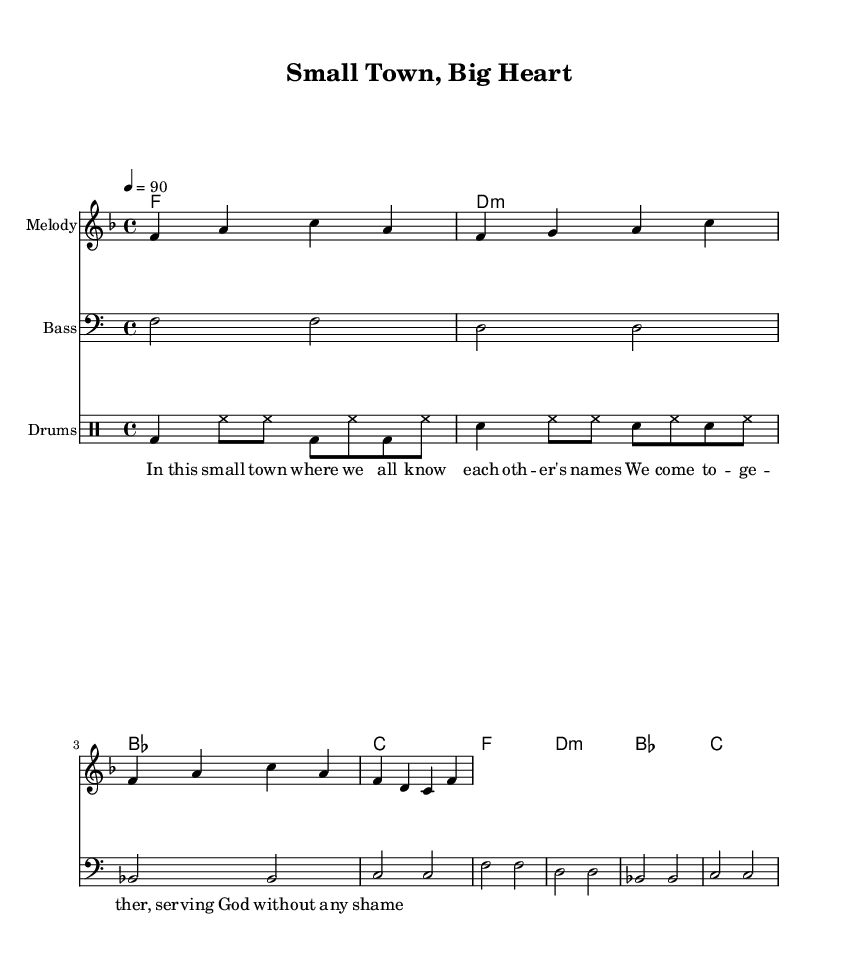What is the title of the piece? The title of the piece is located in the header section of the sheet music. It states "Small Town, Big Heart".
Answer: Small Town, Big Heart What is the time signature of this music? The time signature is indicated near the beginning of the score. It shows a "4/4" which means there are four beats in each measure.
Answer: 4/4 What is the key signature of this music? The key signature is indicated at the beginning of the piece. It shows one flat, which signifies that the piece is in F major.
Answer: F major What is the tempo marking for this piece? The tempo marking is found within the global settings of the score. It indicates "4 = 90", meaning there are 90 beats per minute.
Answer: 90 How many measures are in the melody? The melody section consists of two repeated phrases, each containing four measures. Therefore, there are a total of 8 measures in the melody.
Answer: 8 Which instrument has a bass line in the score? The score includes a specific staff labeled "Bass," indicating that this part is intended for a bass instrument.
Answer: Bass What are the main themes explored in the lyrics? The lyrics depict themes of community and service, as they mention coming together and serving God in a small-town setting.
Answer: Community and service 